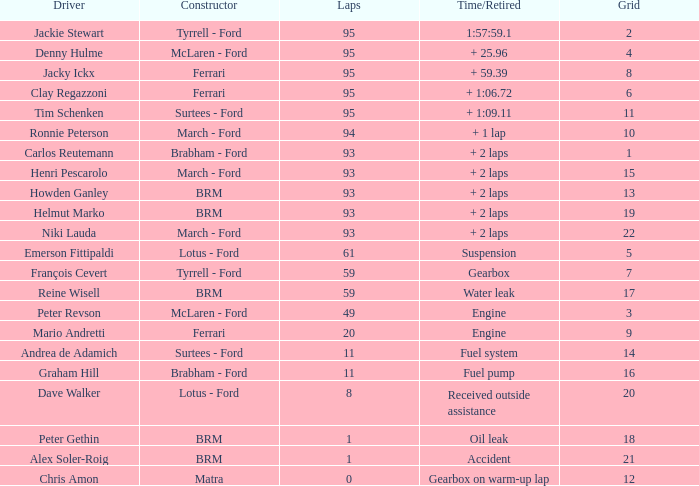Can you parse all the data within this table? {'header': ['Driver', 'Constructor', 'Laps', 'Time/Retired', 'Grid'], 'rows': [['Jackie Stewart', 'Tyrrell - Ford', '95', '1:57:59.1', '2'], ['Denny Hulme', 'McLaren - Ford', '95', '+ 25.96', '4'], ['Jacky Ickx', 'Ferrari', '95', '+ 59.39', '8'], ['Clay Regazzoni', 'Ferrari', '95', '+ 1:06.72', '6'], ['Tim Schenken', 'Surtees - Ford', '95', '+ 1:09.11', '11'], ['Ronnie Peterson', 'March - Ford', '94', '+ 1 lap', '10'], ['Carlos Reutemann', 'Brabham - Ford', '93', '+ 2 laps', '1'], ['Henri Pescarolo', 'March - Ford', '93', '+ 2 laps', '15'], ['Howden Ganley', 'BRM', '93', '+ 2 laps', '13'], ['Helmut Marko', 'BRM', '93', '+ 2 laps', '19'], ['Niki Lauda', 'March - Ford', '93', '+ 2 laps', '22'], ['Emerson Fittipaldi', 'Lotus - Ford', '61', 'Suspension', '5'], ['François Cevert', 'Tyrrell - Ford', '59', 'Gearbox', '7'], ['Reine Wisell', 'BRM', '59', 'Water leak', '17'], ['Peter Revson', 'McLaren - Ford', '49', 'Engine', '3'], ['Mario Andretti', 'Ferrari', '20', 'Engine', '9'], ['Andrea de Adamich', 'Surtees - Ford', '11', 'Fuel system', '14'], ['Graham Hill', 'Brabham - Ford', '11', 'Fuel pump', '16'], ['Dave Walker', 'Lotus - Ford', '8', 'Received outside assistance', '20'], ['Peter Gethin', 'BRM', '1', 'Oil leak', '18'], ['Alex Soler-Roig', 'BRM', '1', 'Accident', '21'], ['Chris Amon', 'Matra', '0', 'Gearbox on warm-up lap', '12']]} How many grids does dave walker have? 1.0. 